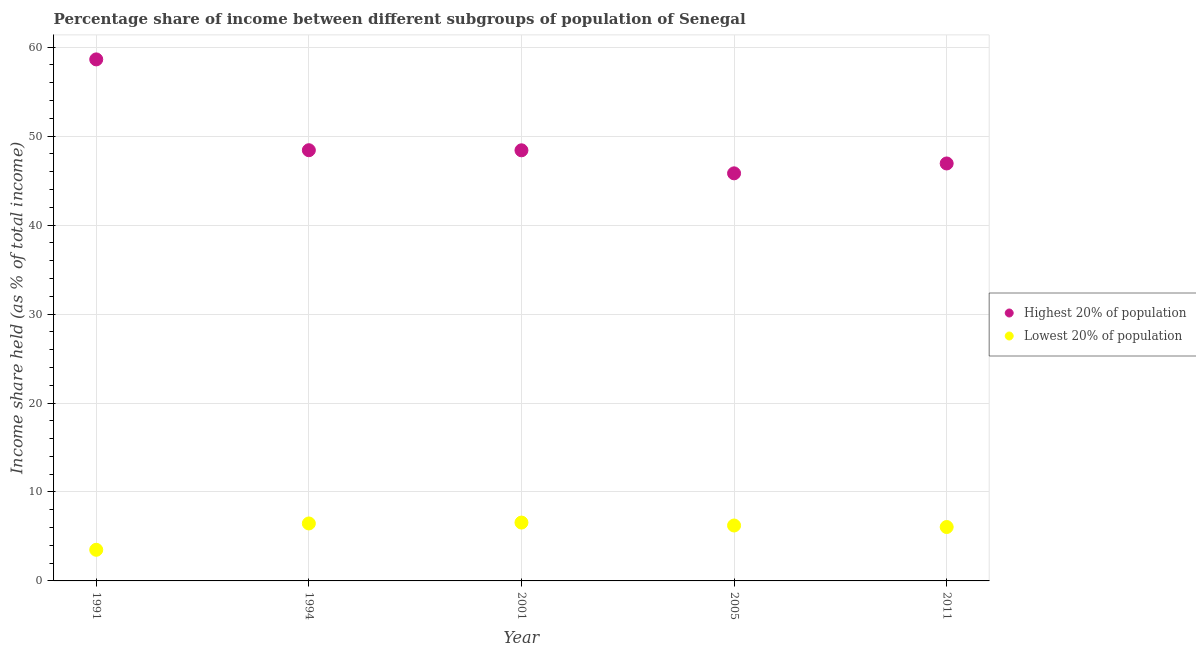Is the number of dotlines equal to the number of legend labels?
Your response must be concise. Yes. What is the income share held by lowest 20% of the population in 2005?
Make the answer very short. 6.23. Across all years, what is the maximum income share held by lowest 20% of the population?
Provide a succinct answer. 6.56. Across all years, what is the minimum income share held by highest 20% of the population?
Offer a very short reply. 45.82. In which year was the income share held by highest 20% of the population minimum?
Your answer should be compact. 2005. What is the total income share held by highest 20% of the population in the graph?
Your answer should be compact. 248.21. What is the difference between the income share held by lowest 20% of the population in 1994 and that in 2001?
Keep it short and to the point. -0.1. What is the difference between the income share held by highest 20% of the population in 2011 and the income share held by lowest 20% of the population in 2001?
Offer a very short reply. 40.37. What is the average income share held by highest 20% of the population per year?
Offer a terse response. 49.64. In the year 1994, what is the difference between the income share held by highest 20% of the population and income share held by lowest 20% of the population?
Provide a short and direct response. 41.96. In how many years, is the income share held by highest 20% of the population greater than 14 %?
Your answer should be very brief. 5. What is the ratio of the income share held by lowest 20% of the population in 2001 to that in 2011?
Your answer should be very brief. 1.08. Is the difference between the income share held by lowest 20% of the population in 1991 and 2011 greater than the difference between the income share held by highest 20% of the population in 1991 and 2011?
Ensure brevity in your answer.  No. What is the difference between the highest and the second highest income share held by lowest 20% of the population?
Ensure brevity in your answer.  0.1. What is the difference between the highest and the lowest income share held by lowest 20% of the population?
Offer a very short reply. 3.06. In how many years, is the income share held by highest 20% of the population greater than the average income share held by highest 20% of the population taken over all years?
Your response must be concise. 1. Is the income share held by highest 20% of the population strictly greater than the income share held by lowest 20% of the population over the years?
Offer a terse response. Yes. Is the income share held by highest 20% of the population strictly less than the income share held by lowest 20% of the population over the years?
Your response must be concise. No. How many dotlines are there?
Your answer should be very brief. 2. How many years are there in the graph?
Ensure brevity in your answer.  5. What is the difference between two consecutive major ticks on the Y-axis?
Your answer should be very brief. 10. Does the graph contain any zero values?
Keep it short and to the point. No. Does the graph contain grids?
Make the answer very short. Yes. Where does the legend appear in the graph?
Your answer should be very brief. Center right. How many legend labels are there?
Ensure brevity in your answer.  2. How are the legend labels stacked?
Your answer should be compact. Vertical. What is the title of the graph?
Your answer should be compact. Percentage share of income between different subgroups of population of Senegal. What is the label or title of the X-axis?
Offer a very short reply. Year. What is the label or title of the Y-axis?
Offer a very short reply. Income share held (as % of total income). What is the Income share held (as % of total income) of Highest 20% of population in 1991?
Keep it short and to the point. 58.63. What is the Income share held (as % of total income) of Highest 20% of population in 1994?
Your response must be concise. 48.42. What is the Income share held (as % of total income) of Lowest 20% of population in 1994?
Keep it short and to the point. 6.46. What is the Income share held (as % of total income) of Highest 20% of population in 2001?
Keep it short and to the point. 48.41. What is the Income share held (as % of total income) in Lowest 20% of population in 2001?
Ensure brevity in your answer.  6.56. What is the Income share held (as % of total income) in Highest 20% of population in 2005?
Your response must be concise. 45.82. What is the Income share held (as % of total income) in Lowest 20% of population in 2005?
Provide a short and direct response. 6.23. What is the Income share held (as % of total income) in Highest 20% of population in 2011?
Your answer should be very brief. 46.93. What is the Income share held (as % of total income) in Lowest 20% of population in 2011?
Your response must be concise. 6.06. Across all years, what is the maximum Income share held (as % of total income) of Highest 20% of population?
Offer a very short reply. 58.63. Across all years, what is the maximum Income share held (as % of total income) in Lowest 20% of population?
Your answer should be compact. 6.56. Across all years, what is the minimum Income share held (as % of total income) of Highest 20% of population?
Your response must be concise. 45.82. Across all years, what is the minimum Income share held (as % of total income) in Lowest 20% of population?
Offer a very short reply. 3.5. What is the total Income share held (as % of total income) of Highest 20% of population in the graph?
Give a very brief answer. 248.21. What is the total Income share held (as % of total income) of Lowest 20% of population in the graph?
Make the answer very short. 28.81. What is the difference between the Income share held (as % of total income) of Highest 20% of population in 1991 and that in 1994?
Your answer should be very brief. 10.21. What is the difference between the Income share held (as % of total income) in Lowest 20% of population in 1991 and that in 1994?
Your answer should be compact. -2.96. What is the difference between the Income share held (as % of total income) of Highest 20% of population in 1991 and that in 2001?
Ensure brevity in your answer.  10.22. What is the difference between the Income share held (as % of total income) of Lowest 20% of population in 1991 and that in 2001?
Provide a short and direct response. -3.06. What is the difference between the Income share held (as % of total income) in Highest 20% of population in 1991 and that in 2005?
Offer a terse response. 12.81. What is the difference between the Income share held (as % of total income) of Lowest 20% of population in 1991 and that in 2005?
Keep it short and to the point. -2.73. What is the difference between the Income share held (as % of total income) of Highest 20% of population in 1991 and that in 2011?
Provide a short and direct response. 11.7. What is the difference between the Income share held (as % of total income) in Lowest 20% of population in 1991 and that in 2011?
Provide a succinct answer. -2.56. What is the difference between the Income share held (as % of total income) in Highest 20% of population in 1994 and that in 2001?
Offer a very short reply. 0.01. What is the difference between the Income share held (as % of total income) in Lowest 20% of population in 1994 and that in 2001?
Offer a terse response. -0.1. What is the difference between the Income share held (as % of total income) in Highest 20% of population in 1994 and that in 2005?
Offer a very short reply. 2.6. What is the difference between the Income share held (as % of total income) in Lowest 20% of population in 1994 and that in 2005?
Ensure brevity in your answer.  0.23. What is the difference between the Income share held (as % of total income) in Highest 20% of population in 1994 and that in 2011?
Give a very brief answer. 1.49. What is the difference between the Income share held (as % of total income) of Highest 20% of population in 2001 and that in 2005?
Ensure brevity in your answer.  2.59. What is the difference between the Income share held (as % of total income) in Lowest 20% of population in 2001 and that in 2005?
Provide a short and direct response. 0.33. What is the difference between the Income share held (as % of total income) of Highest 20% of population in 2001 and that in 2011?
Make the answer very short. 1.48. What is the difference between the Income share held (as % of total income) in Lowest 20% of population in 2001 and that in 2011?
Your answer should be compact. 0.5. What is the difference between the Income share held (as % of total income) in Highest 20% of population in 2005 and that in 2011?
Offer a terse response. -1.11. What is the difference between the Income share held (as % of total income) in Lowest 20% of population in 2005 and that in 2011?
Your response must be concise. 0.17. What is the difference between the Income share held (as % of total income) in Highest 20% of population in 1991 and the Income share held (as % of total income) in Lowest 20% of population in 1994?
Offer a terse response. 52.17. What is the difference between the Income share held (as % of total income) of Highest 20% of population in 1991 and the Income share held (as % of total income) of Lowest 20% of population in 2001?
Keep it short and to the point. 52.07. What is the difference between the Income share held (as % of total income) in Highest 20% of population in 1991 and the Income share held (as % of total income) in Lowest 20% of population in 2005?
Your response must be concise. 52.4. What is the difference between the Income share held (as % of total income) in Highest 20% of population in 1991 and the Income share held (as % of total income) in Lowest 20% of population in 2011?
Offer a terse response. 52.57. What is the difference between the Income share held (as % of total income) in Highest 20% of population in 1994 and the Income share held (as % of total income) in Lowest 20% of population in 2001?
Keep it short and to the point. 41.86. What is the difference between the Income share held (as % of total income) of Highest 20% of population in 1994 and the Income share held (as % of total income) of Lowest 20% of population in 2005?
Offer a very short reply. 42.19. What is the difference between the Income share held (as % of total income) of Highest 20% of population in 1994 and the Income share held (as % of total income) of Lowest 20% of population in 2011?
Keep it short and to the point. 42.36. What is the difference between the Income share held (as % of total income) of Highest 20% of population in 2001 and the Income share held (as % of total income) of Lowest 20% of population in 2005?
Provide a succinct answer. 42.18. What is the difference between the Income share held (as % of total income) of Highest 20% of population in 2001 and the Income share held (as % of total income) of Lowest 20% of population in 2011?
Your response must be concise. 42.35. What is the difference between the Income share held (as % of total income) of Highest 20% of population in 2005 and the Income share held (as % of total income) of Lowest 20% of population in 2011?
Your answer should be compact. 39.76. What is the average Income share held (as % of total income) of Highest 20% of population per year?
Provide a succinct answer. 49.64. What is the average Income share held (as % of total income) in Lowest 20% of population per year?
Ensure brevity in your answer.  5.76. In the year 1991, what is the difference between the Income share held (as % of total income) in Highest 20% of population and Income share held (as % of total income) in Lowest 20% of population?
Provide a short and direct response. 55.13. In the year 1994, what is the difference between the Income share held (as % of total income) in Highest 20% of population and Income share held (as % of total income) in Lowest 20% of population?
Give a very brief answer. 41.96. In the year 2001, what is the difference between the Income share held (as % of total income) in Highest 20% of population and Income share held (as % of total income) in Lowest 20% of population?
Your response must be concise. 41.85. In the year 2005, what is the difference between the Income share held (as % of total income) of Highest 20% of population and Income share held (as % of total income) of Lowest 20% of population?
Provide a succinct answer. 39.59. In the year 2011, what is the difference between the Income share held (as % of total income) of Highest 20% of population and Income share held (as % of total income) of Lowest 20% of population?
Offer a very short reply. 40.87. What is the ratio of the Income share held (as % of total income) of Highest 20% of population in 1991 to that in 1994?
Your answer should be compact. 1.21. What is the ratio of the Income share held (as % of total income) of Lowest 20% of population in 1991 to that in 1994?
Provide a short and direct response. 0.54. What is the ratio of the Income share held (as % of total income) of Highest 20% of population in 1991 to that in 2001?
Offer a terse response. 1.21. What is the ratio of the Income share held (as % of total income) of Lowest 20% of population in 1991 to that in 2001?
Your answer should be compact. 0.53. What is the ratio of the Income share held (as % of total income) of Highest 20% of population in 1991 to that in 2005?
Your answer should be very brief. 1.28. What is the ratio of the Income share held (as % of total income) of Lowest 20% of population in 1991 to that in 2005?
Ensure brevity in your answer.  0.56. What is the ratio of the Income share held (as % of total income) in Highest 20% of population in 1991 to that in 2011?
Provide a short and direct response. 1.25. What is the ratio of the Income share held (as % of total income) of Lowest 20% of population in 1991 to that in 2011?
Offer a very short reply. 0.58. What is the ratio of the Income share held (as % of total income) of Highest 20% of population in 1994 to that in 2001?
Your answer should be compact. 1. What is the ratio of the Income share held (as % of total income) in Lowest 20% of population in 1994 to that in 2001?
Your answer should be compact. 0.98. What is the ratio of the Income share held (as % of total income) of Highest 20% of population in 1994 to that in 2005?
Make the answer very short. 1.06. What is the ratio of the Income share held (as % of total income) of Lowest 20% of population in 1994 to that in 2005?
Provide a succinct answer. 1.04. What is the ratio of the Income share held (as % of total income) in Highest 20% of population in 1994 to that in 2011?
Provide a short and direct response. 1.03. What is the ratio of the Income share held (as % of total income) of Lowest 20% of population in 1994 to that in 2011?
Make the answer very short. 1.07. What is the ratio of the Income share held (as % of total income) in Highest 20% of population in 2001 to that in 2005?
Your answer should be very brief. 1.06. What is the ratio of the Income share held (as % of total income) of Lowest 20% of population in 2001 to that in 2005?
Make the answer very short. 1.05. What is the ratio of the Income share held (as % of total income) of Highest 20% of population in 2001 to that in 2011?
Your answer should be very brief. 1.03. What is the ratio of the Income share held (as % of total income) in Lowest 20% of population in 2001 to that in 2011?
Provide a succinct answer. 1.08. What is the ratio of the Income share held (as % of total income) of Highest 20% of population in 2005 to that in 2011?
Make the answer very short. 0.98. What is the ratio of the Income share held (as % of total income) in Lowest 20% of population in 2005 to that in 2011?
Provide a short and direct response. 1.03. What is the difference between the highest and the second highest Income share held (as % of total income) of Highest 20% of population?
Offer a very short reply. 10.21. What is the difference between the highest and the lowest Income share held (as % of total income) in Highest 20% of population?
Ensure brevity in your answer.  12.81. What is the difference between the highest and the lowest Income share held (as % of total income) in Lowest 20% of population?
Offer a very short reply. 3.06. 